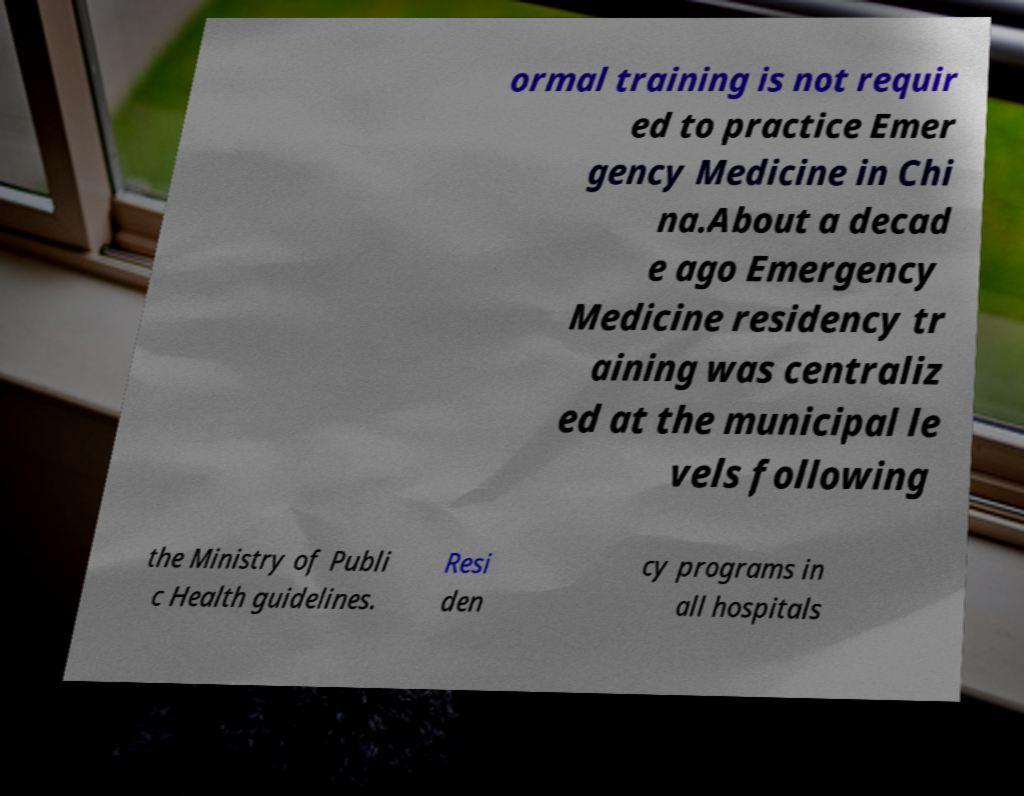Please identify and transcribe the text found in this image. ormal training is not requir ed to practice Emer gency Medicine in Chi na.About a decad e ago Emergency Medicine residency tr aining was centraliz ed at the municipal le vels following the Ministry of Publi c Health guidelines. Resi den cy programs in all hospitals 